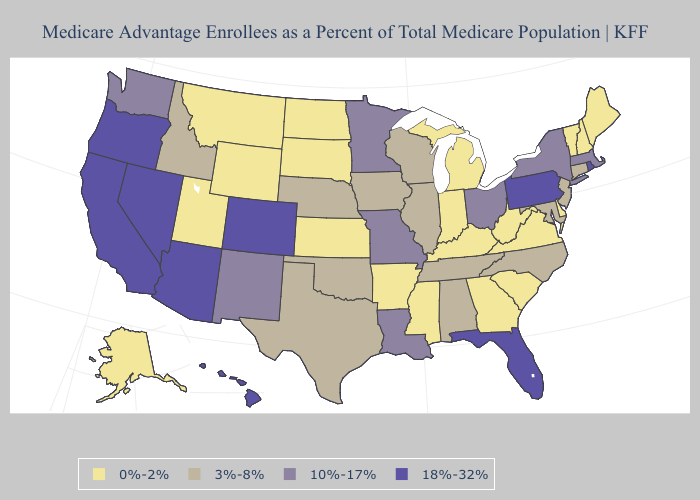What is the lowest value in the South?
Quick response, please. 0%-2%. Name the states that have a value in the range 3%-8%?
Be succinct. Alabama, Connecticut, Iowa, Idaho, Illinois, Maryland, North Carolina, Nebraska, New Jersey, Oklahoma, Tennessee, Texas, Wisconsin. What is the lowest value in the Northeast?
Keep it brief. 0%-2%. What is the lowest value in the USA?
Answer briefly. 0%-2%. Among the states that border Wyoming , does Colorado have the highest value?
Quick response, please. Yes. Which states have the highest value in the USA?
Concise answer only. Arizona, California, Colorado, Florida, Hawaii, Nevada, Oregon, Pennsylvania, Rhode Island. What is the value of Wyoming?
Write a very short answer. 0%-2%. What is the value of Missouri?
Be succinct. 10%-17%. What is the value of Montana?
Keep it brief. 0%-2%. Name the states that have a value in the range 18%-32%?
Quick response, please. Arizona, California, Colorado, Florida, Hawaii, Nevada, Oregon, Pennsylvania, Rhode Island. Name the states that have a value in the range 10%-17%?
Keep it brief. Louisiana, Massachusetts, Minnesota, Missouri, New Mexico, New York, Ohio, Washington. Among the states that border New York , which have the lowest value?
Give a very brief answer. Vermont. What is the highest value in the West ?
Concise answer only. 18%-32%. Name the states that have a value in the range 0%-2%?
Write a very short answer. Alaska, Arkansas, Delaware, Georgia, Indiana, Kansas, Kentucky, Maine, Michigan, Mississippi, Montana, North Dakota, New Hampshire, South Carolina, South Dakota, Utah, Virginia, Vermont, West Virginia, Wyoming. What is the value of Hawaii?
Answer briefly. 18%-32%. 